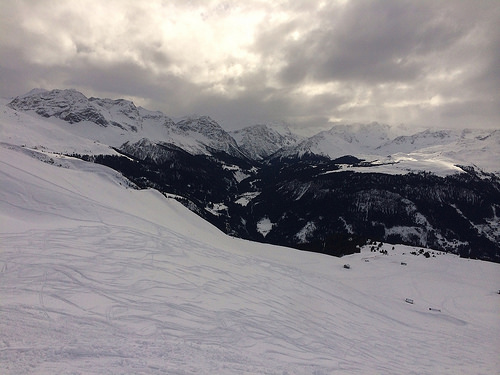<image>
Is there a mountain in front of the snow? No. The mountain is not in front of the snow. The spatial positioning shows a different relationship between these objects. 